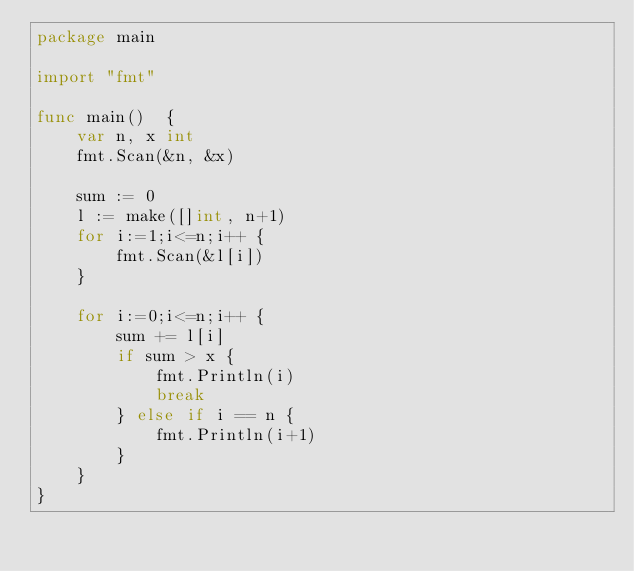Convert code to text. <code><loc_0><loc_0><loc_500><loc_500><_Go_>package main

import "fmt"

func main()  {
	var n, x int
	fmt.Scan(&n, &x)

	sum := 0
	l := make([]int, n+1)
	for i:=1;i<=n;i++ {
		fmt.Scan(&l[i])
	}

	for i:=0;i<=n;i++ {
		sum += l[i]
		if sum > x {
			fmt.Println(i)
			break
		} else if i == n {
			fmt.Println(i+1)
		}
	}
}</code> 